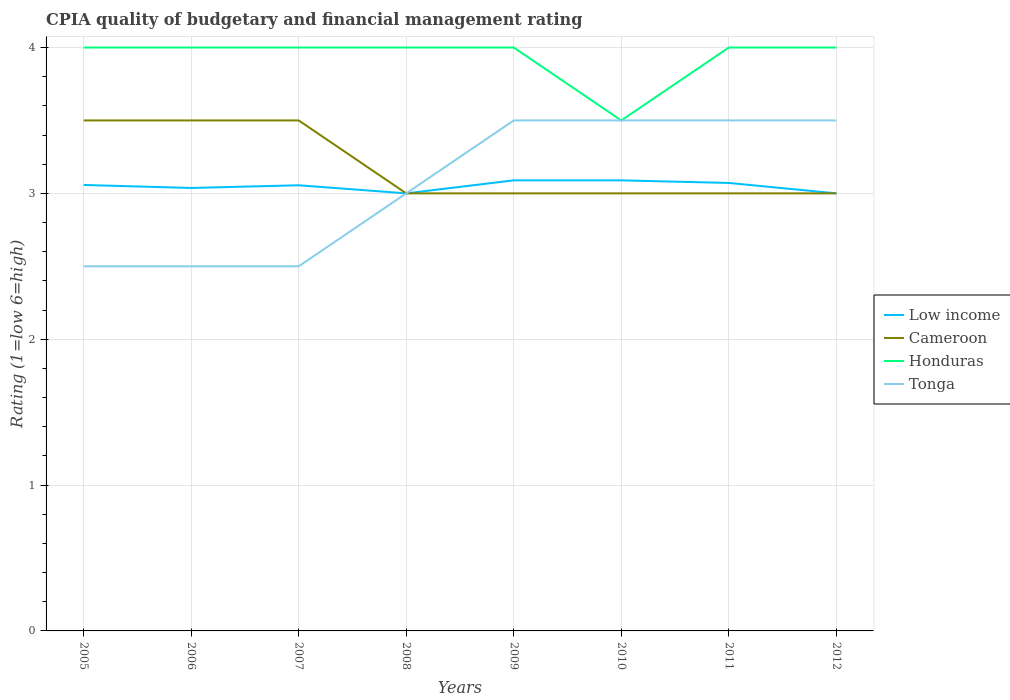Does the line corresponding to Low income intersect with the line corresponding to Cameroon?
Offer a terse response. Yes. Is the number of lines equal to the number of legend labels?
Offer a very short reply. Yes. In which year was the CPIA rating in Cameroon maximum?
Your answer should be very brief. 2008. What is the total CPIA rating in Honduras in the graph?
Your answer should be compact. 0. Is the CPIA rating in Tonga strictly greater than the CPIA rating in Cameroon over the years?
Your response must be concise. No. How many years are there in the graph?
Provide a succinct answer. 8. What is the difference between two consecutive major ticks on the Y-axis?
Offer a terse response. 1. Are the values on the major ticks of Y-axis written in scientific E-notation?
Offer a terse response. No. What is the title of the graph?
Your response must be concise. CPIA quality of budgetary and financial management rating. Does "Congo (Republic)" appear as one of the legend labels in the graph?
Offer a very short reply. No. What is the label or title of the Y-axis?
Your response must be concise. Rating (1=low 6=high). What is the Rating (1=low 6=high) of Low income in 2005?
Offer a terse response. 3.06. What is the Rating (1=low 6=high) in Tonga in 2005?
Your answer should be very brief. 2.5. What is the Rating (1=low 6=high) in Low income in 2006?
Your answer should be very brief. 3.04. What is the Rating (1=low 6=high) in Cameroon in 2006?
Make the answer very short. 3.5. What is the Rating (1=low 6=high) of Honduras in 2006?
Your answer should be compact. 4. What is the Rating (1=low 6=high) of Tonga in 2006?
Ensure brevity in your answer.  2.5. What is the Rating (1=low 6=high) in Low income in 2007?
Keep it short and to the point. 3.06. What is the Rating (1=low 6=high) in Cameroon in 2007?
Offer a terse response. 3.5. What is the Rating (1=low 6=high) of Honduras in 2007?
Give a very brief answer. 4. What is the Rating (1=low 6=high) in Tonga in 2007?
Provide a short and direct response. 2.5. What is the Rating (1=low 6=high) of Cameroon in 2008?
Offer a very short reply. 3. What is the Rating (1=low 6=high) in Honduras in 2008?
Offer a very short reply. 4. What is the Rating (1=low 6=high) in Tonga in 2008?
Your answer should be compact. 3. What is the Rating (1=low 6=high) of Low income in 2009?
Your answer should be very brief. 3.09. What is the Rating (1=low 6=high) in Cameroon in 2009?
Keep it short and to the point. 3. What is the Rating (1=low 6=high) in Honduras in 2009?
Your response must be concise. 4. What is the Rating (1=low 6=high) in Tonga in 2009?
Your answer should be compact. 3.5. What is the Rating (1=low 6=high) in Low income in 2010?
Your answer should be very brief. 3.09. What is the Rating (1=low 6=high) of Cameroon in 2010?
Offer a terse response. 3. What is the Rating (1=low 6=high) of Tonga in 2010?
Provide a succinct answer. 3.5. What is the Rating (1=low 6=high) of Low income in 2011?
Your answer should be very brief. 3.07. What is the Rating (1=low 6=high) of Cameroon in 2011?
Your answer should be compact. 3. What is the Rating (1=low 6=high) in Honduras in 2011?
Provide a succinct answer. 4. What is the Rating (1=low 6=high) of Tonga in 2011?
Give a very brief answer. 3.5. What is the Rating (1=low 6=high) of Cameroon in 2012?
Provide a short and direct response. 3. What is the Rating (1=low 6=high) in Honduras in 2012?
Keep it short and to the point. 4. What is the Rating (1=low 6=high) of Tonga in 2012?
Offer a very short reply. 3.5. Across all years, what is the maximum Rating (1=low 6=high) of Low income?
Your answer should be very brief. 3.09. Across all years, what is the maximum Rating (1=low 6=high) of Tonga?
Make the answer very short. 3.5. Across all years, what is the minimum Rating (1=low 6=high) of Low income?
Provide a short and direct response. 3. Across all years, what is the minimum Rating (1=low 6=high) in Cameroon?
Ensure brevity in your answer.  3. Across all years, what is the minimum Rating (1=low 6=high) of Tonga?
Ensure brevity in your answer.  2.5. What is the total Rating (1=low 6=high) of Low income in the graph?
Make the answer very short. 24.4. What is the total Rating (1=low 6=high) in Cameroon in the graph?
Your answer should be compact. 25.5. What is the total Rating (1=low 6=high) of Honduras in the graph?
Your answer should be compact. 31.5. What is the total Rating (1=low 6=high) in Tonga in the graph?
Your response must be concise. 24.5. What is the difference between the Rating (1=low 6=high) of Low income in 2005 and that in 2006?
Offer a terse response. 0.02. What is the difference between the Rating (1=low 6=high) of Cameroon in 2005 and that in 2006?
Provide a succinct answer. 0. What is the difference between the Rating (1=low 6=high) in Tonga in 2005 and that in 2006?
Make the answer very short. 0. What is the difference between the Rating (1=low 6=high) of Low income in 2005 and that in 2007?
Give a very brief answer. 0. What is the difference between the Rating (1=low 6=high) in Cameroon in 2005 and that in 2007?
Offer a very short reply. 0. What is the difference between the Rating (1=low 6=high) of Low income in 2005 and that in 2008?
Your response must be concise. 0.06. What is the difference between the Rating (1=low 6=high) in Cameroon in 2005 and that in 2008?
Offer a very short reply. 0.5. What is the difference between the Rating (1=low 6=high) of Tonga in 2005 and that in 2008?
Keep it short and to the point. -0.5. What is the difference between the Rating (1=low 6=high) of Low income in 2005 and that in 2009?
Provide a succinct answer. -0.03. What is the difference between the Rating (1=low 6=high) of Low income in 2005 and that in 2010?
Make the answer very short. -0.03. What is the difference between the Rating (1=low 6=high) of Cameroon in 2005 and that in 2010?
Make the answer very short. 0.5. What is the difference between the Rating (1=low 6=high) of Low income in 2005 and that in 2011?
Provide a short and direct response. -0.01. What is the difference between the Rating (1=low 6=high) of Cameroon in 2005 and that in 2011?
Give a very brief answer. 0.5. What is the difference between the Rating (1=low 6=high) of Tonga in 2005 and that in 2011?
Your answer should be very brief. -1. What is the difference between the Rating (1=low 6=high) of Low income in 2005 and that in 2012?
Ensure brevity in your answer.  0.06. What is the difference between the Rating (1=low 6=high) in Low income in 2006 and that in 2007?
Keep it short and to the point. -0.02. What is the difference between the Rating (1=low 6=high) in Tonga in 2006 and that in 2007?
Provide a succinct answer. 0. What is the difference between the Rating (1=low 6=high) of Low income in 2006 and that in 2008?
Ensure brevity in your answer.  0.04. What is the difference between the Rating (1=low 6=high) of Cameroon in 2006 and that in 2008?
Your response must be concise. 0.5. What is the difference between the Rating (1=low 6=high) of Tonga in 2006 and that in 2008?
Offer a very short reply. -0.5. What is the difference between the Rating (1=low 6=high) in Low income in 2006 and that in 2009?
Give a very brief answer. -0.05. What is the difference between the Rating (1=low 6=high) of Cameroon in 2006 and that in 2009?
Your answer should be compact. 0.5. What is the difference between the Rating (1=low 6=high) in Honduras in 2006 and that in 2009?
Your answer should be compact. 0. What is the difference between the Rating (1=low 6=high) of Tonga in 2006 and that in 2009?
Offer a very short reply. -1. What is the difference between the Rating (1=low 6=high) of Low income in 2006 and that in 2010?
Offer a very short reply. -0.05. What is the difference between the Rating (1=low 6=high) of Cameroon in 2006 and that in 2010?
Your response must be concise. 0.5. What is the difference between the Rating (1=low 6=high) in Low income in 2006 and that in 2011?
Offer a very short reply. -0.03. What is the difference between the Rating (1=low 6=high) in Tonga in 2006 and that in 2011?
Your response must be concise. -1. What is the difference between the Rating (1=low 6=high) of Low income in 2006 and that in 2012?
Ensure brevity in your answer.  0.04. What is the difference between the Rating (1=low 6=high) in Cameroon in 2006 and that in 2012?
Provide a short and direct response. 0.5. What is the difference between the Rating (1=low 6=high) of Honduras in 2006 and that in 2012?
Your response must be concise. 0. What is the difference between the Rating (1=low 6=high) of Low income in 2007 and that in 2008?
Give a very brief answer. 0.06. What is the difference between the Rating (1=low 6=high) of Cameroon in 2007 and that in 2008?
Ensure brevity in your answer.  0.5. What is the difference between the Rating (1=low 6=high) in Honduras in 2007 and that in 2008?
Provide a short and direct response. 0. What is the difference between the Rating (1=low 6=high) of Low income in 2007 and that in 2009?
Your answer should be compact. -0.03. What is the difference between the Rating (1=low 6=high) in Honduras in 2007 and that in 2009?
Ensure brevity in your answer.  0. What is the difference between the Rating (1=low 6=high) in Low income in 2007 and that in 2010?
Offer a terse response. -0.03. What is the difference between the Rating (1=low 6=high) of Honduras in 2007 and that in 2010?
Offer a very short reply. 0.5. What is the difference between the Rating (1=low 6=high) of Low income in 2007 and that in 2011?
Give a very brief answer. -0.02. What is the difference between the Rating (1=low 6=high) in Honduras in 2007 and that in 2011?
Ensure brevity in your answer.  0. What is the difference between the Rating (1=low 6=high) of Low income in 2007 and that in 2012?
Your answer should be very brief. 0.06. What is the difference between the Rating (1=low 6=high) of Honduras in 2007 and that in 2012?
Offer a terse response. 0. What is the difference between the Rating (1=low 6=high) in Tonga in 2007 and that in 2012?
Your answer should be very brief. -1. What is the difference between the Rating (1=low 6=high) of Low income in 2008 and that in 2009?
Give a very brief answer. -0.09. What is the difference between the Rating (1=low 6=high) in Cameroon in 2008 and that in 2009?
Offer a very short reply. 0. What is the difference between the Rating (1=low 6=high) in Low income in 2008 and that in 2010?
Provide a short and direct response. -0.09. What is the difference between the Rating (1=low 6=high) of Tonga in 2008 and that in 2010?
Provide a succinct answer. -0.5. What is the difference between the Rating (1=low 6=high) of Low income in 2008 and that in 2011?
Your response must be concise. -0.07. What is the difference between the Rating (1=low 6=high) in Honduras in 2008 and that in 2011?
Offer a terse response. 0. What is the difference between the Rating (1=low 6=high) of Tonga in 2008 and that in 2011?
Your answer should be compact. -0.5. What is the difference between the Rating (1=low 6=high) in Cameroon in 2008 and that in 2012?
Give a very brief answer. 0. What is the difference between the Rating (1=low 6=high) in Honduras in 2008 and that in 2012?
Offer a terse response. 0. What is the difference between the Rating (1=low 6=high) of Tonga in 2008 and that in 2012?
Give a very brief answer. -0.5. What is the difference between the Rating (1=low 6=high) of Low income in 2009 and that in 2010?
Your answer should be very brief. 0. What is the difference between the Rating (1=low 6=high) in Cameroon in 2009 and that in 2010?
Offer a terse response. 0. What is the difference between the Rating (1=low 6=high) of Tonga in 2009 and that in 2010?
Offer a very short reply. 0. What is the difference between the Rating (1=low 6=high) in Low income in 2009 and that in 2011?
Provide a short and direct response. 0.02. What is the difference between the Rating (1=low 6=high) in Honduras in 2009 and that in 2011?
Provide a succinct answer. 0. What is the difference between the Rating (1=low 6=high) of Low income in 2009 and that in 2012?
Provide a short and direct response. 0.09. What is the difference between the Rating (1=low 6=high) in Cameroon in 2009 and that in 2012?
Your answer should be very brief. 0. What is the difference between the Rating (1=low 6=high) in Honduras in 2009 and that in 2012?
Keep it short and to the point. 0. What is the difference between the Rating (1=low 6=high) of Tonga in 2009 and that in 2012?
Ensure brevity in your answer.  0. What is the difference between the Rating (1=low 6=high) of Low income in 2010 and that in 2011?
Make the answer very short. 0.02. What is the difference between the Rating (1=low 6=high) of Cameroon in 2010 and that in 2011?
Offer a very short reply. 0. What is the difference between the Rating (1=low 6=high) of Honduras in 2010 and that in 2011?
Make the answer very short. -0.5. What is the difference between the Rating (1=low 6=high) of Low income in 2010 and that in 2012?
Provide a short and direct response. 0.09. What is the difference between the Rating (1=low 6=high) of Cameroon in 2010 and that in 2012?
Your response must be concise. 0. What is the difference between the Rating (1=low 6=high) in Honduras in 2010 and that in 2012?
Your answer should be compact. -0.5. What is the difference between the Rating (1=low 6=high) of Tonga in 2010 and that in 2012?
Keep it short and to the point. 0. What is the difference between the Rating (1=low 6=high) in Low income in 2011 and that in 2012?
Your response must be concise. 0.07. What is the difference between the Rating (1=low 6=high) of Cameroon in 2011 and that in 2012?
Your answer should be compact. 0. What is the difference between the Rating (1=low 6=high) in Low income in 2005 and the Rating (1=low 6=high) in Cameroon in 2006?
Offer a terse response. -0.44. What is the difference between the Rating (1=low 6=high) of Low income in 2005 and the Rating (1=low 6=high) of Honduras in 2006?
Give a very brief answer. -0.94. What is the difference between the Rating (1=low 6=high) of Low income in 2005 and the Rating (1=low 6=high) of Tonga in 2006?
Provide a succinct answer. 0.56. What is the difference between the Rating (1=low 6=high) in Cameroon in 2005 and the Rating (1=low 6=high) in Honduras in 2006?
Provide a short and direct response. -0.5. What is the difference between the Rating (1=low 6=high) in Low income in 2005 and the Rating (1=low 6=high) in Cameroon in 2007?
Your response must be concise. -0.44. What is the difference between the Rating (1=low 6=high) in Low income in 2005 and the Rating (1=low 6=high) in Honduras in 2007?
Your answer should be very brief. -0.94. What is the difference between the Rating (1=low 6=high) of Low income in 2005 and the Rating (1=low 6=high) of Tonga in 2007?
Your answer should be very brief. 0.56. What is the difference between the Rating (1=low 6=high) of Cameroon in 2005 and the Rating (1=low 6=high) of Honduras in 2007?
Ensure brevity in your answer.  -0.5. What is the difference between the Rating (1=low 6=high) in Honduras in 2005 and the Rating (1=low 6=high) in Tonga in 2007?
Give a very brief answer. 1.5. What is the difference between the Rating (1=low 6=high) in Low income in 2005 and the Rating (1=low 6=high) in Cameroon in 2008?
Your answer should be very brief. 0.06. What is the difference between the Rating (1=low 6=high) in Low income in 2005 and the Rating (1=low 6=high) in Honduras in 2008?
Keep it short and to the point. -0.94. What is the difference between the Rating (1=low 6=high) of Low income in 2005 and the Rating (1=low 6=high) of Tonga in 2008?
Offer a terse response. 0.06. What is the difference between the Rating (1=low 6=high) in Cameroon in 2005 and the Rating (1=low 6=high) in Tonga in 2008?
Your response must be concise. 0.5. What is the difference between the Rating (1=low 6=high) in Low income in 2005 and the Rating (1=low 6=high) in Cameroon in 2009?
Your response must be concise. 0.06. What is the difference between the Rating (1=low 6=high) of Low income in 2005 and the Rating (1=low 6=high) of Honduras in 2009?
Your response must be concise. -0.94. What is the difference between the Rating (1=low 6=high) of Low income in 2005 and the Rating (1=low 6=high) of Tonga in 2009?
Your answer should be compact. -0.44. What is the difference between the Rating (1=low 6=high) of Cameroon in 2005 and the Rating (1=low 6=high) of Honduras in 2009?
Your response must be concise. -0.5. What is the difference between the Rating (1=low 6=high) in Low income in 2005 and the Rating (1=low 6=high) in Cameroon in 2010?
Make the answer very short. 0.06. What is the difference between the Rating (1=low 6=high) of Low income in 2005 and the Rating (1=low 6=high) of Honduras in 2010?
Offer a terse response. -0.44. What is the difference between the Rating (1=low 6=high) in Low income in 2005 and the Rating (1=low 6=high) in Tonga in 2010?
Your answer should be compact. -0.44. What is the difference between the Rating (1=low 6=high) in Low income in 2005 and the Rating (1=low 6=high) in Cameroon in 2011?
Your answer should be very brief. 0.06. What is the difference between the Rating (1=low 6=high) of Low income in 2005 and the Rating (1=low 6=high) of Honduras in 2011?
Give a very brief answer. -0.94. What is the difference between the Rating (1=low 6=high) in Low income in 2005 and the Rating (1=low 6=high) in Tonga in 2011?
Offer a very short reply. -0.44. What is the difference between the Rating (1=low 6=high) of Cameroon in 2005 and the Rating (1=low 6=high) of Honduras in 2011?
Keep it short and to the point. -0.5. What is the difference between the Rating (1=low 6=high) of Low income in 2005 and the Rating (1=low 6=high) of Cameroon in 2012?
Provide a succinct answer. 0.06. What is the difference between the Rating (1=low 6=high) in Low income in 2005 and the Rating (1=low 6=high) in Honduras in 2012?
Offer a terse response. -0.94. What is the difference between the Rating (1=low 6=high) in Low income in 2005 and the Rating (1=low 6=high) in Tonga in 2012?
Make the answer very short. -0.44. What is the difference between the Rating (1=low 6=high) of Cameroon in 2005 and the Rating (1=low 6=high) of Honduras in 2012?
Keep it short and to the point. -0.5. What is the difference between the Rating (1=low 6=high) in Cameroon in 2005 and the Rating (1=low 6=high) in Tonga in 2012?
Offer a terse response. 0. What is the difference between the Rating (1=low 6=high) in Low income in 2006 and the Rating (1=low 6=high) in Cameroon in 2007?
Offer a very short reply. -0.46. What is the difference between the Rating (1=low 6=high) in Low income in 2006 and the Rating (1=low 6=high) in Honduras in 2007?
Offer a terse response. -0.96. What is the difference between the Rating (1=low 6=high) in Low income in 2006 and the Rating (1=low 6=high) in Tonga in 2007?
Your response must be concise. 0.54. What is the difference between the Rating (1=low 6=high) of Cameroon in 2006 and the Rating (1=low 6=high) of Honduras in 2007?
Make the answer very short. -0.5. What is the difference between the Rating (1=low 6=high) in Cameroon in 2006 and the Rating (1=low 6=high) in Tonga in 2007?
Provide a succinct answer. 1. What is the difference between the Rating (1=low 6=high) of Low income in 2006 and the Rating (1=low 6=high) of Cameroon in 2008?
Ensure brevity in your answer.  0.04. What is the difference between the Rating (1=low 6=high) of Low income in 2006 and the Rating (1=low 6=high) of Honduras in 2008?
Your answer should be very brief. -0.96. What is the difference between the Rating (1=low 6=high) in Low income in 2006 and the Rating (1=low 6=high) in Tonga in 2008?
Your response must be concise. 0.04. What is the difference between the Rating (1=low 6=high) of Cameroon in 2006 and the Rating (1=low 6=high) of Honduras in 2008?
Keep it short and to the point. -0.5. What is the difference between the Rating (1=low 6=high) in Cameroon in 2006 and the Rating (1=low 6=high) in Tonga in 2008?
Keep it short and to the point. 0.5. What is the difference between the Rating (1=low 6=high) of Low income in 2006 and the Rating (1=low 6=high) of Cameroon in 2009?
Ensure brevity in your answer.  0.04. What is the difference between the Rating (1=low 6=high) in Low income in 2006 and the Rating (1=low 6=high) in Honduras in 2009?
Keep it short and to the point. -0.96. What is the difference between the Rating (1=low 6=high) of Low income in 2006 and the Rating (1=low 6=high) of Tonga in 2009?
Your response must be concise. -0.46. What is the difference between the Rating (1=low 6=high) in Low income in 2006 and the Rating (1=low 6=high) in Cameroon in 2010?
Keep it short and to the point. 0.04. What is the difference between the Rating (1=low 6=high) in Low income in 2006 and the Rating (1=low 6=high) in Honduras in 2010?
Your answer should be compact. -0.46. What is the difference between the Rating (1=low 6=high) of Low income in 2006 and the Rating (1=low 6=high) of Tonga in 2010?
Offer a very short reply. -0.46. What is the difference between the Rating (1=low 6=high) of Cameroon in 2006 and the Rating (1=low 6=high) of Honduras in 2010?
Offer a terse response. 0. What is the difference between the Rating (1=low 6=high) of Honduras in 2006 and the Rating (1=low 6=high) of Tonga in 2010?
Offer a terse response. 0.5. What is the difference between the Rating (1=low 6=high) in Low income in 2006 and the Rating (1=low 6=high) in Cameroon in 2011?
Make the answer very short. 0.04. What is the difference between the Rating (1=low 6=high) in Low income in 2006 and the Rating (1=low 6=high) in Honduras in 2011?
Your answer should be very brief. -0.96. What is the difference between the Rating (1=low 6=high) in Low income in 2006 and the Rating (1=low 6=high) in Tonga in 2011?
Ensure brevity in your answer.  -0.46. What is the difference between the Rating (1=low 6=high) in Honduras in 2006 and the Rating (1=low 6=high) in Tonga in 2011?
Provide a short and direct response. 0.5. What is the difference between the Rating (1=low 6=high) in Low income in 2006 and the Rating (1=low 6=high) in Cameroon in 2012?
Give a very brief answer. 0.04. What is the difference between the Rating (1=low 6=high) in Low income in 2006 and the Rating (1=low 6=high) in Honduras in 2012?
Provide a succinct answer. -0.96. What is the difference between the Rating (1=low 6=high) in Low income in 2006 and the Rating (1=low 6=high) in Tonga in 2012?
Provide a short and direct response. -0.46. What is the difference between the Rating (1=low 6=high) of Cameroon in 2006 and the Rating (1=low 6=high) of Honduras in 2012?
Offer a terse response. -0.5. What is the difference between the Rating (1=low 6=high) in Honduras in 2006 and the Rating (1=low 6=high) in Tonga in 2012?
Your answer should be compact. 0.5. What is the difference between the Rating (1=low 6=high) of Low income in 2007 and the Rating (1=low 6=high) of Cameroon in 2008?
Provide a short and direct response. 0.06. What is the difference between the Rating (1=low 6=high) in Low income in 2007 and the Rating (1=low 6=high) in Honduras in 2008?
Provide a short and direct response. -0.94. What is the difference between the Rating (1=low 6=high) in Low income in 2007 and the Rating (1=low 6=high) in Tonga in 2008?
Ensure brevity in your answer.  0.06. What is the difference between the Rating (1=low 6=high) of Low income in 2007 and the Rating (1=low 6=high) of Cameroon in 2009?
Make the answer very short. 0.06. What is the difference between the Rating (1=low 6=high) in Low income in 2007 and the Rating (1=low 6=high) in Honduras in 2009?
Ensure brevity in your answer.  -0.94. What is the difference between the Rating (1=low 6=high) in Low income in 2007 and the Rating (1=low 6=high) in Tonga in 2009?
Keep it short and to the point. -0.44. What is the difference between the Rating (1=low 6=high) of Cameroon in 2007 and the Rating (1=low 6=high) of Honduras in 2009?
Give a very brief answer. -0.5. What is the difference between the Rating (1=low 6=high) of Cameroon in 2007 and the Rating (1=low 6=high) of Tonga in 2009?
Ensure brevity in your answer.  0. What is the difference between the Rating (1=low 6=high) of Low income in 2007 and the Rating (1=low 6=high) of Cameroon in 2010?
Your response must be concise. 0.06. What is the difference between the Rating (1=low 6=high) of Low income in 2007 and the Rating (1=low 6=high) of Honduras in 2010?
Offer a very short reply. -0.44. What is the difference between the Rating (1=low 6=high) of Low income in 2007 and the Rating (1=low 6=high) of Tonga in 2010?
Your answer should be very brief. -0.44. What is the difference between the Rating (1=low 6=high) of Honduras in 2007 and the Rating (1=low 6=high) of Tonga in 2010?
Give a very brief answer. 0.5. What is the difference between the Rating (1=low 6=high) in Low income in 2007 and the Rating (1=low 6=high) in Cameroon in 2011?
Provide a short and direct response. 0.06. What is the difference between the Rating (1=low 6=high) in Low income in 2007 and the Rating (1=low 6=high) in Honduras in 2011?
Provide a succinct answer. -0.94. What is the difference between the Rating (1=low 6=high) of Low income in 2007 and the Rating (1=low 6=high) of Tonga in 2011?
Your answer should be compact. -0.44. What is the difference between the Rating (1=low 6=high) of Cameroon in 2007 and the Rating (1=low 6=high) of Tonga in 2011?
Provide a succinct answer. 0. What is the difference between the Rating (1=low 6=high) of Honduras in 2007 and the Rating (1=low 6=high) of Tonga in 2011?
Your answer should be very brief. 0.5. What is the difference between the Rating (1=low 6=high) of Low income in 2007 and the Rating (1=low 6=high) of Cameroon in 2012?
Offer a very short reply. 0.06. What is the difference between the Rating (1=low 6=high) in Low income in 2007 and the Rating (1=low 6=high) in Honduras in 2012?
Your answer should be compact. -0.94. What is the difference between the Rating (1=low 6=high) in Low income in 2007 and the Rating (1=low 6=high) in Tonga in 2012?
Offer a terse response. -0.44. What is the difference between the Rating (1=low 6=high) in Cameroon in 2007 and the Rating (1=low 6=high) in Honduras in 2012?
Offer a very short reply. -0.5. What is the difference between the Rating (1=low 6=high) in Cameroon in 2007 and the Rating (1=low 6=high) in Tonga in 2012?
Your answer should be very brief. 0. What is the difference between the Rating (1=low 6=high) of Honduras in 2007 and the Rating (1=low 6=high) of Tonga in 2012?
Provide a succinct answer. 0.5. What is the difference between the Rating (1=low 6=high) of Cameroon in 2008 and the Rating (1=low 6=high) of Honduras in 2009?
Your answer should be very brief. -1. What is the difference between the Rating (1=low 6=high) in Cameroon in 2008 and the Rating (1=low 6=high) in Tonga in 2009?
Make the answer very short. -0.5. What is the difference between the Rating (1=low 6=high) of Low income in 2008 and the Rating (1=low 6=high) of Tonga in 2010?
Make the answer very short. -0.5. What is the difference between the Rating (1=low 6=high) in Cameroon in 2008 and the Rating (1=low 6=high) in Honduras in 2010?
Provide a short and direct response. -0.5. What is the difference between the Rating (1=low 6=high) of Honduras in 2008 and the Rating (1=low 6=high) of Tonga in 2010?
Your response must be concise. 0.5. What is the difference between the Rating (1=low 6=high) in Low income in 2008 and the Rating (1=low 6=high) in Honduras in 2011?
Your answer should be very brief. -1. What is the difference between the Rating (1=low 6=high) of Low income in 2008 and the Rating (1=low 6=high) of Tonga in 2011?
Offer a terse response. -0.5. What is the difference between the Rating (1=low 6=high) in Low income in 2008 and the Rating (1=low 6=high) in Tonga in 2012?
Ensure brevity in your answer.  -0.5. What is the difference between the Rating (1=low 6=high) in Honduras in 2008 and the Rating (1=low 6=high) in Tonga in 2012?
Your answer should be very brief. 0.5. What is the difference between the Rating (1=low 6=high) in Low income in 2009 and the Rating (1=low 6=high) in Cameroon in 2010?
Provide a short and direct response. 0.09. What is the difference between the Rating (1=low 6=high) of Low income in 2009 and the Rating (1=low 6=high) of Honduras in 2010?
Provide a short and direct response. -0.41. What is the difference between the Rating (1=low 6=high) in Low income in 2009 and the Rating (1=low 6=high) in Tonga in 2010?
Make the answer very short. -0.41. What is the difference between the Rating (1=low 6=high) in Cameroon in 2009 and the Rating (1=low 6=high) in Tonga in 2010?
Offer a very short reply. -0.5. What is the difference between the Rating (1=low 6=high) in Honduras in 2009 and the Rating (1=low 6=high) in Tonga in 2010?
Offer a very short reply. 0.5. What is the difference between the Rating (1=low 6=high) in Low income in 2009 and the Rating (1=low 6=high) in Cameroon in 2011?
Your answer should be compact. 0.09. What is the difference between the Rating (1=low 6=high) of Low income in 2009 and the Rating (1=low 6=high) of Honduras in 2011?
Give a very brief answer. -0.91. What is the difference between the Rating (1=low 6=high) in Low income in 2009 and the Rating (1=low 6=high) in Tonga in 2011?
Make the answer very short. -0.41. What is the difference between the Rating (1=low 6=high) of Honduras in 2009 and the Rating (1=low 6=high) of Tonga in 2011?
Your response must be concise. 0.5. What is the difference between the Rating (1=low 6=high) in Low income in 2009 and the Rating (1=low 6=high) in Cameroon in 2012?
Offer a terse response. 0.09. What is the difference between the Rating (1=low 6=high) in Low income in 2009 and the Rating (1=low 6=high) in Honduras in 2012?
Give a very brief answer. -0.91. What is the difference between the Rating (1=low 6=high) in Low income in 2009 and the Rating (1=low 6=high) in Tonga in 2012?
Make the answer very short. -0.41. What is the difference between the Rating (1=low 6=high) of Cameroon in 2009 and the Rating (1=low 6=high) of Honduras in 2012?
Make the answer very short. -1. What is the difference between the Rating (1=low 6=high) of Cameroon in 2009 and the Rating (1=low 6=high) of Tonga in 2012?
Offer a terse response. -0.5. What is the difference between the Rating (1=low 6=high) in Low income in 2010 and the Rating (1=low 6=high) in Cameroon in 2011?
Your answer should be very brief. 0.09. What is the difference between the Rating (1=low 6=high) of Low income in 2010 and the Rating (1=low 6=high) of Honduras in 2011?
Keep it short and to the point. -0.91. What is the difference between the Rating (1=low 6=high) of Low income in 2010 and the Rating (1=low 6=high) of Tonga in 2011?
Ensure brevity in your answer.  -0.41. What is the difference between the Rating (1=low 6=high) in Cameroon in 2010 and the Rating (1=low 6=high) in Tonga in 2011?
Your answer should be compact. -0.5. What is the difference between the Rating (1=low 6=high) in Honduras in 2010 and the Rating (1=low 6=high) in Tonga in 2011?
Keep it short and to the point. 0. What is the difference between the Rating (1=low 6=high) in Low income in 2010 and the Rating (1=low 6=high) in Cameroon in 2012?
Your answer should be compact. 0.09. What is the difference between the Rating (1=low 6=high) of Low income in 2010 and the Rating (1=low 6=high) of Honduras in 2012?
Provide a succinct answer. -0.91. What is the difference between the Rating (1=low 6=high) of Low income in 2010 and the Rating (1=low 6=high) of Tonga in 2012?
Your answer should be very brief. -0.41. What is the difference between the Rating (1=low 6=high) in Low income in 2011 and the Rating (1=low 6=high) in Cameroon in 2012?
Offer a terse response. 0.07. What is the difference between the Rating (1=low 6=high) of Low income in 2011 and the Rating (1=low 6=high) of Honduras in 2012?
Your answer should be very brief. -0.93. What is the difference between the Rating (1=low 6=high) of Low income in 2011 and the Rating (1=low 6=high) of Tonga in 2012?
Offer a very short reply. -0.43. What is the difference between the Rating (1=low 6=high) of Cameroon in 2011 and the Rating (1=low 6=high) of Honduras in 2012?
Your response must be concise. -1. What is the average Rating (1=low 6=high) in Low income per year?
Keep it short and to the point. 3.05. What is the average Rating (1=low 6=high) in Cameroon per year?
Offer a terse response. 3.19. What is the average Rating (1=low 6=high) of Honduras per year?
Offer a terse response. 3.94. What is the average Rating (1=low 6=high) of Tonga per year?
Provide a succinct answer. 3.06. In the year 2005, what is the difference between the Rating (1=low 6=high) in Low income and Rating (1=low 6=high) in Cameroon?
Your answer should be compact. -0.44. In the year 2005, what is the difference between the Rating (1=low 6=high) in Low income and Rating (1=low 6=high) in Honduras?
Make the answer very short. -0.94. In the year 2005, what is the difference between the Rating (1=low 6=high) in Low income and Rating (1=low 6=high) in Tonga?
Give a very brief answer. 0.56. In the year 2006, what is the difference between the Rating (1=low 6=high) of Low income and Rating (1=low 6=high) of Cameroon?
Make the answer very short. -0.46. In the year 2006, what is the difference between the Rating (1=low 6=high) in Low income and Rating (1=low 6=high) in Honduras?
Make the answer very short. -0.96. In the year 2006, what is the difference between the Rating (1=low 6=high) in Low income and Rating (1=low 6=high) in Tonga?
Make the answer very short. 0.54. In the year 2007, what is the difference between the Rating (1=low 6=high) of Low income and Rating (1=low 6=high) of Cameroon?
Your response must be concise. -0.44. In the year 2007, what is the difference between the Rating (1=low 6=high) in Low income and Rating (1=low 6=high) in Honduras?
Make the answer very short. -0.94. In the year 2007, what is the difference between the Rating (1=low 6=high) in Low income and Rating (1=low 6=high) in Tonga?
Your response must be concise. 0.56. In the year 2007, what is the difference between the Rating (1=low 6=high) in Honduras and Rating (1=low 6=high) in Tonga?
Offer a very short reply. 1.5. In the year 2008, what is the difference between the Rating (1=low 6=high) in Low income and Rating (1=low 6=high) in Honduras?
Offer a terse response. -1. In the year 2008, what is the difference between the Rating (1=low 6=high) in Cameroon and Rating (1=low 6=high) in Honduras?
Your answer should be compact. -1. In the year 2008, what is the difference between the Rating (1=low 6=high) of Cameroon and Rating (1=low 6=high) of Tonga?
Provide a succinct answer. 0. In the year 2008, what is the difference between the Rating (1=low 6=high) in Honduras and Rating (1=low 6=high) in Tonga?
Give a very brief answer. 1. In the year 2009, what is the difference between the Rating (1=low 6=high) in Low income and Rating (1=low 6=high) in Cameroon?
Give a very brief answer. 0.09. In the year 2009, what is the difference between the Rating (1=low 6=high) of Low income and Rating (1=low 6=high) of Honduras?
Your answer should be very brief. -0.91. In the year 2009, what is the difference between the Rating (1=low 6=high) of Low income and Rating (1=low 6=high) of Tonga?
Offer a very short reply. -0.41. In the year 2009, what is the difference between the Rating (1=low 6=high) of Cameroon and Rating (1=low 6=high) of Honduras?
Keep it short and to the point. -1. In the year 2009, what is the difference between the Rating (1=low 6=high) in Cameroon and Rating (1=low 6=high) in Tonga?
Your response must be concise. -0.5. In the year 2009, what is the difference between the Rating (1=low 6=high) in Honduras and Rating (1=low 6=high) in Tonga?
Give a very brief answer. 0.5. In the year 2010, what is the difference between the Rating (1=low 6=high) of Low income and Rating (1=low 6=high) of Cameroon?
Keep it short and to the point. 0.09. In the year 2010, what is the difference between the Rating (1=low 6=high) in Low income and Rating (1=low 6=high) in Honduras?
Provide a short and direct response. -0.41. In the year 2010, what is the difference between the Rating (1=low 6=high) of Low income and Rating (1=low 6=high) of Tonga?
Give a very brief answer. -0.41. In the year 2010, what is the difference between the Rating (1=low 6=high) in Cameroon and Rating (1=low 6=high) in Honduras?
Make the answer very short. -0.5. In the year 2010, what is the difference between the Rating (1=low 6=high) in Cameroon and Rating (1=low 6=high) in Tonga?
Provide a short and direct response. -0.5. In the year 2010, what is the difference between the Rating (1=low 6=high) of Honduras and Rating (1=low 6=high) of Tonga?
Your response must be concise. 0. In the year 2011, what is the difference between the Rating (1=low 6=high) of Low income and Rating (1=low 6=high) of Cameroon?
Ensure brevity in your answer.  0.07. In the year 2011, what is the difference between the Rating (1=low 6=high) of Low income and Rating (1=low 6=high) of Honduras?
Keep it short and to the point. -0.93. In the year 2011, what is the difference between the Rating (1=low 6=high) of Low income and Rating (1=low 6=high) of Tonga?
Offer a terse response. -0.43. In the year 2011, what is the difference between the Rating (1=low 6=high) of Cameroon and Rating (1=low 6=high) of Honduras?
Make the answer very short. -1. In the year 2012, what is the difference between the Rating (1=low 6=high) of Low income and Rating (1=low 6=high) of Tonga?
Give a very brief answer. -0.5. In the year 2012, what is the difference between the Rating (1=low 6=high) of Cameroon and Rating (1=low 6=high) of Tonga?
Offer a very short reply. -0.5. In the year 2012, what is the difference between the Rating (1=low 6=high) in Honduras and Rating (1=low 6=high) in Tonga?
Provide a short and direct response. 0.5. What is the ratio of the Rating (1=low 6=high) in Low income in 2005 to that in 2006?
Provide a succinct answer. 1.01. What is the ratio of the Rating (1=low 6=high) of Honduras in 2005 to that in 2006?
Provide a short and direct response. 1. What is the ratio of the Rating (1=low 6=high) in Cameroon in 2005 to that in 2007?
Your answer should be compact. 1. What is the ratio of the Rating (1=low 6=high) in Honduras in 2005 to that in 2007?
Your answer should be compact. 1. What is the ratio of the Rating (1=low 6=high) of Low income in 2005 to that in 2008?
Make the answer very short. 1.02. What is the ratio of the Rating (1=low 6=high) in Tonga in 2005 to that in 2008?
Your answer should be compact. 0.83. What is the ratio of the Rating (1=low 6=high) in Cameroon in 2005 to that in 2009?
Provide a short and direct response. 1.17. What is the ratio of the Rating (1=low 6=high) of Honduras in 2005 to that in 2009?
Make the answer very short. 1. What is the ratio of the Rating (1=low 6=high) of Cameroon in 2005 to that in 2010?
Make the answer very short. 1.17. What is the ratio of the Rating (1=low 6=high) in Tonga in 2005 to that in 2010?
Your answer should be compact. 0.71. What is the ratio of the Rating (1=low 6=high) in Low income in 2005 to that in 2011?
Ensure brevity in your answer.  1. What is the ratio of the Rating (1=low 6=high) in Honduras in 2005 to that in 2011?
Your answer should be very brief. 1. What is the ratio of the Rating (1=low 6=high) of Tonga in 2005 to that in 2011?
Your answer should be compact. 0.71. What is the ratio of the Rating (1=low 6=high) in Low income in 2005 to that in 2012?
Provide a succinct answer. 1.02. What is the ratio of the Rating (1=low 6=high) of Honduras in 2005 to that in 2012?
Give a very brief answer. 1. What is the ratio of the Rating (1=low 6=high) in Tonga in 2005 to that in 2012?
Ensure brevity in your answer.  0.71. What is the ratio of the Rating (1=low 6=high) of Low income in 2006 to that in 2007?
Offer a terse response. 0.99. What is the ratio of the Rating (1=low 6=high) of Honduras in 2006 to that in 2007?
Give a very brief answer. 1. What is the ratio of the Rating (1=low 6=high) in Low income in 2006 to that in 2008?
Ensure brevity in your answer.  1.01. What is the ratio of the Rating (1=low 6=high) of Cameroon in 2006 to that in 2008?
Offer a very short reply. 1.17. What is the ratio of the Rating (1=low 6=high) in Low income in 2006 to that in 2009?
Offer a very short reply. 0.98. What is the ratio of the Rating (1=low 6=high) of Honduras in 2006 to that in 2009?
Ensure brevity in your answer.  1. What is the ratio of the Rating (1=low 6=high) in Tonga in 2006 to that in 2009?
Keep it short and to the point. 0.71. What is the ratio of the Rating (1=low 6=high) in Low income in 2006 to that in 2010?
Your answer should be very brief. 0.98. What is the ratio of the Rating (1=low 6=high) in Tonga in 2006 to that in 2010?
Ensure brevity in your answer.  0.71. What is the ratio of the Rating (1=low 6=high) of Low income in 2006 to that in 2011?
Your answer should be compact. 0.99. What is the ratio of the Rating (1=low 6=high) of Cameroon in 2006 to that in 2011?
Your response must be concise. 1.17. What is the ratio of the Rating (1=low 6=high) in Honduras in 2006 to that in 2011?
Ensure brevity in your answer.  1. What is the ratio of the Rating (1=low 6=high) of Tonga in 2006 to that in 2011?
Offer a terse response. 0.71. What is the ratio of the Rating (1=low 6=high) of Low income in 2006 to that in 2012?
Provide a succinct answer. 1.01. What is the ratio of the Rating (1=low 6=high) of Tonga in 2006 to that in 2012?
Offer a very short reply. 0.71. What is the ratio of the Rating (1=low 6=high) in Low income in 2007 to that in 2008?
Ensure brevity in your answer.  1.02. What is the ratio of the Rating (1=low 6=high) of Cameroon in 2007 to that in 2008?
Your response must be concise. 1.17. What is the ratio of the Rating (1=low 6=high) of Tonga in 2007 to that in 2008?
Give a very brief answer. 0.83. What is the ratio of the Rating (1=low 6=high) of Low income in 2007 to that in 2009?
Give a very brief answer. 0.99. What is the ratio of the Rating (1=low 6=high) of Cameroon in 2007 to that in 2009?
Ensure brevity in your answer.  1.17. What is the ratio of the Rating (1=low 6=high) in Tonga in 2007 to that in 2009?
Your response must be concise. 0.71. What is the ratio of the Rating (1=low 6=high) of Low income in 2007 to that in 2010?
Your answer should be very brief. 0.99. What is the ratio of the Rating (1=low 6=high) in Cameroon in 2007 to that in 2010?
Give a very brief answer. 1.17. What is the ratio of the Rating (1=low 6=high) in Honduras in 2007 to that in 2010?
Provide a succinct answer. 1.14. What is the ratio of the Rating (1=low 6=high) of Cameroon in 2007 to that in 2011?
Keep it short and to the point. 1.17. What is the ratio of the Rating (1=low 6=high) of Tonga in 2007 to that in 2011?
Offer a very short reply. 0.71. What is the ratio of the Rating (1=low 6=high) in Low income in 2007 to that in 2012?
Provide a short and direct response. 1.02. What is the ratio of the Rating (1=low 6=high) of Honduras in 2007 to that in 2012?
Offer a very short reply. 1. What is the ratio of the Rating (1=low 6=high) of Tonga in 2007 to that in 2012?
Give a very brief answer. 0.71. What is the ratio of the Rating (1=low 6=high) of Low income in 2008 to that in 2009?
Provide a short and direct response. 0.97. What is the ratio of the Rating (1=low 6=high) in Honduras in 2008 to that in 2009?
Offer a terse response. 1. What is the ratio of the Rating (1=low 6=high) in Low income in 2008 to that in 2010?
Give a very brief answer. 0.97. What is the ratio of the Rating (1=low 6=high) of Cameroon in 2008 to that in 2010?
Provide a short and direct response. 1. What is the ratio of the Rating (1=low 6=high) of Honduras in 2008 to that in 2010?
Ensure brevity in your answer.  1.14. What is the ratio of the Rating (1=low 6=high) in Tonga in 2008 to that in 2010?
Offer a terse response. 0.86. What is the ratio of the Rating (1=low 6=high) in Low income in 2008 to that in 2011?
Offer a terse response. 0.98. What is the ratio of the Rating (1=low 6=high) in Tonga in 2008 to that in 2012?
Make the answer very short. 0.86. What is the ratio of the Rating (1=low 6=high) in Honduras in 2009 to that in 2010?
Provide a short and direct response. 1.14. What is the ratio of the Rating (1=low 6=high) of Low income in 2009 to that in 2011?
Offer a very short reply. 1.01. What is the ratio of the Rating (1=low 6=high) in Cameroon in 2009 to that in 2011?
Your answer should be very brief. 1. What is the ratio of the Rating (1=low 6=high) in Low income in 2009 to that in 2012?
Provide a short and direct response. 1.03. What is the ratio of the Rating (1=low 6=high) of Cameroon in 2009 to that in 2012?
Offer a terse response. 1. What is the ratio of the Rating (1=low 6=high) in Honduras in 2009 to that in 2012?
Keep it short and to the point. 1. What is the ratio of the Rating (1=low 6=high) in Tonga in 2009 to that in 2012?
Keep it short and to the point. 1. What is the ratio of the Rating (1=low 6=high) in Low income in 2010 to that in 2011?
Provide a short and direct response. 1.01. What is the ratio of the Rating (1=low 6=high) of Honduras in 2010 to that in 2011?
Your answer should be very brief. 0.88. What is the ratio of the Rating (1=low 6=high) of Tonga in 2010 to that in 2011?
Provide a succinct answer. 1. What is the ratio of the Rating (1=low 6=high) in Low income in 2010 to that in 2012?
Ensure brevity in your answer.  1.03. What is the ratio of the Rating (1=low 6=high) of Honduras in 2010 to that in 2012?
Provide a short and direct response. 0.88. What is the ratio of the Rating (1=low 6=high) of Low income in 2011 to that in 2012?
Provide a succinct answer. 1.02. What is the ratio of the Rating (1=low 6=high) of Cameroon in 2011 to that in 2012?
Keep it short and to the point. 1. What is the ratio of the Rating (1=low 6=high) in Tonga in 2011 to that in 2012?
Ensure brevity in your answer.  1. What is the difference between the highest and the second highest Rating (1=low 6=high) in Honduras?
Provide a succinct answer. 0. What is the difference between the highest and the lowest Rating (1=low 6=high) in Low income?
Your response must be concise. 0.09. What is the difference between the highest and the lowest Rating (1=low 6=high) of Honduras?
Provide a short and direct response. 0.5. 